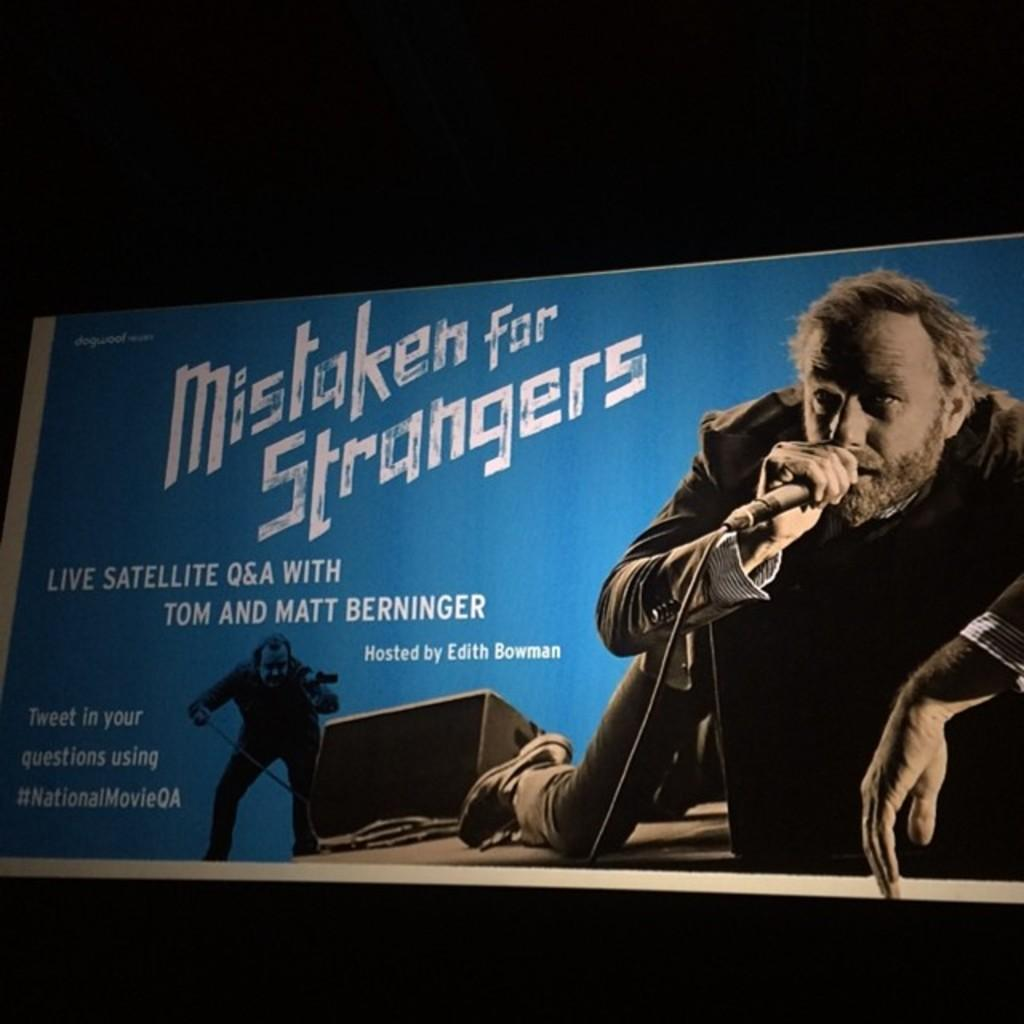What is the color of the poster in the image? The poster in the image is blue. What is depicted on the poster? A person is present on the poster. What is the person holding in the image? The person is holding a microphone. What is the background color of the poster? The background of the poster is black. How many muscles can be seen flexing on the person's arm in the image? There are no muscles visible on the person's arm in the image, as the image only shows the person holding a microphone on a blue poster with a black background. 